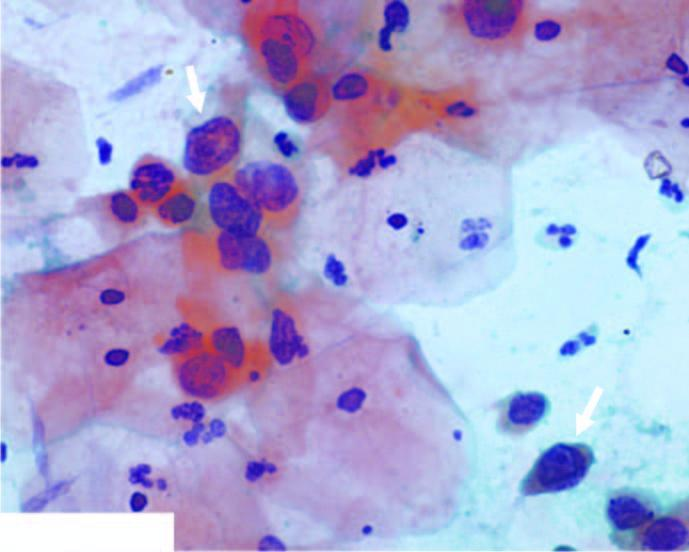what do the squamous cells have?
Answer the question using a single word or phrase. Scanty cytoplasm and markedly hyperchromatic nuclei having irregular nuclear outlines 